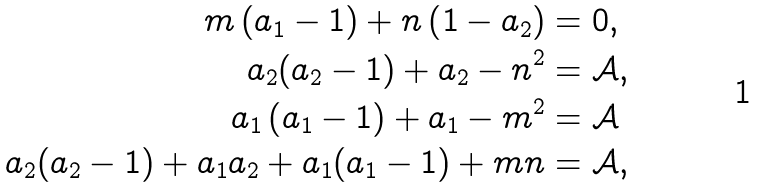Convert formula to latex. <formula><loc_0><loc_0><loc_500><loc_500>m \left ( a _ { 1 } - 1 \right ) + n \left ( 1 - a _ { 2 } \right ) & = 0 , \\ a _ { 2 } ( a _ { 2 } - 1 ) + a _ { 2 } - n ^ { 2 } & = \mathcal { A } , \\ a _ { 1 } \left ( a _ { 1 } - 1 \right ) + a _ { 1 } - m ^ { 2 } & = \mathcal { A } \\ a _ { 2 } ( a _ { 2 } - 1 ) + a _ { 1 } a _ { 2 } + a _ { 1 } ( a _ { 1 } - 1 ) + m n & = \mathcal { A } ,</formula> 